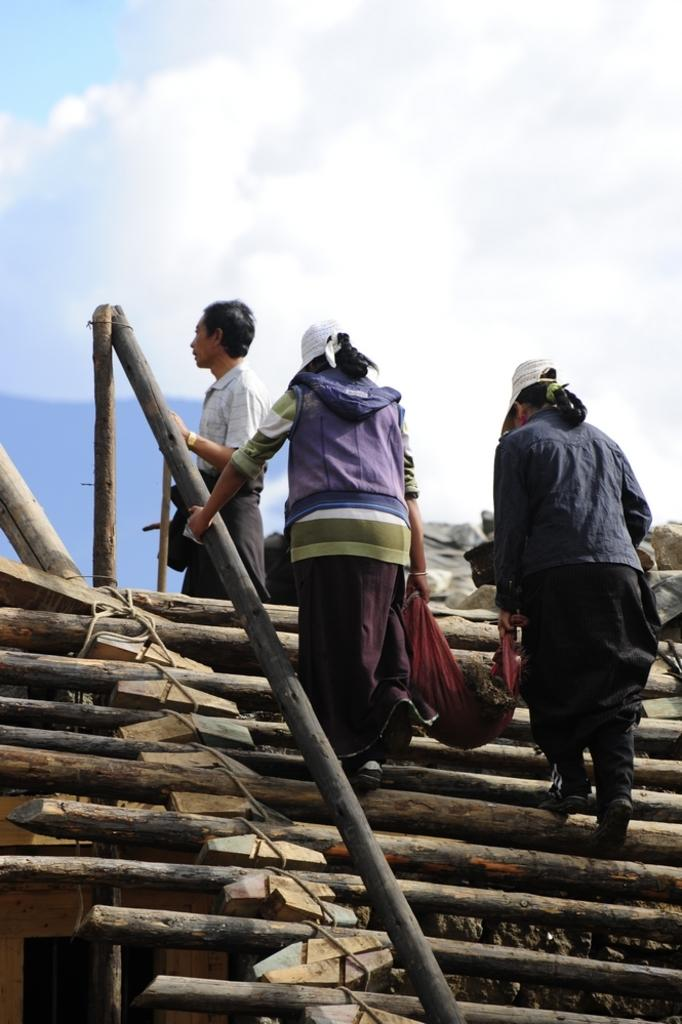What is happening in the image? There are people in the image, and they are climbing stairs. Can you describe the stairs in the image? The stairs are made with wooden logs. What type of sponge can be seen being used by the people in the image? There is no sponge present in the image. What are the people reading while climbing the stairs in the image? There is no indication that the people are reading anything in the image. 